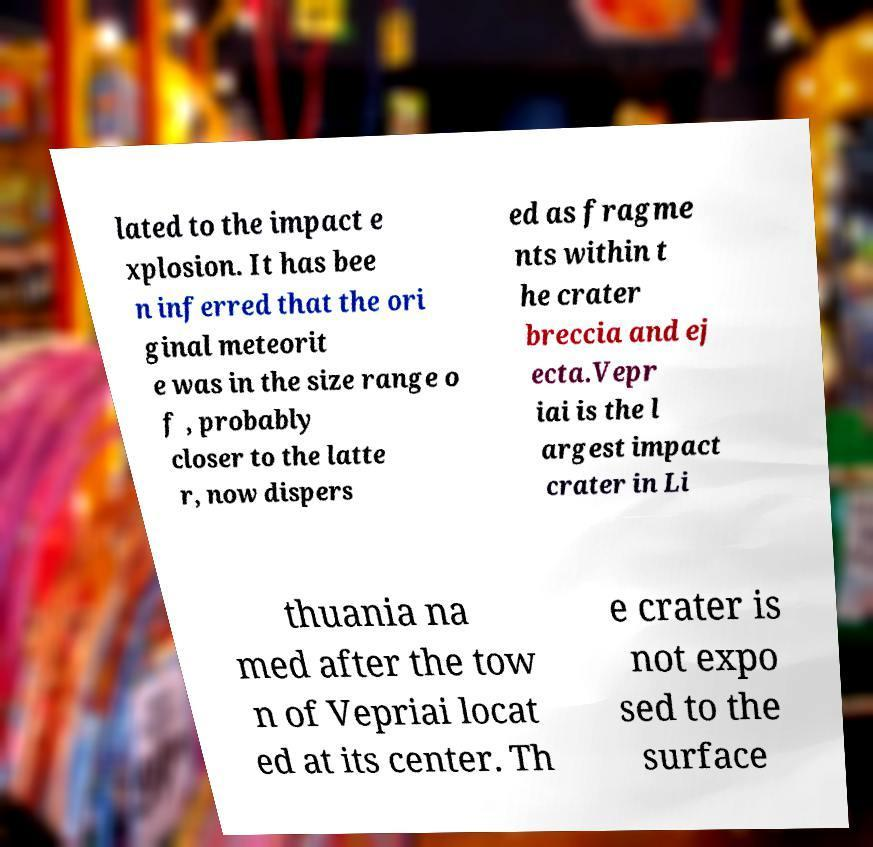Can you accurately transcribe the text from the provided image for me? lated to the impact e xplosion. It has bee n inferred that the ori ginal meteorit e was in the size range o f , probably closer to the latte r, now dispers ed as fragme nts within t he crater breccia and ej ecta.Vepr iai is the l argest impact crater in Li thuania na med after the tow n of Vepriai locat ed at its center. Th e crater is not expo sed to the surface 